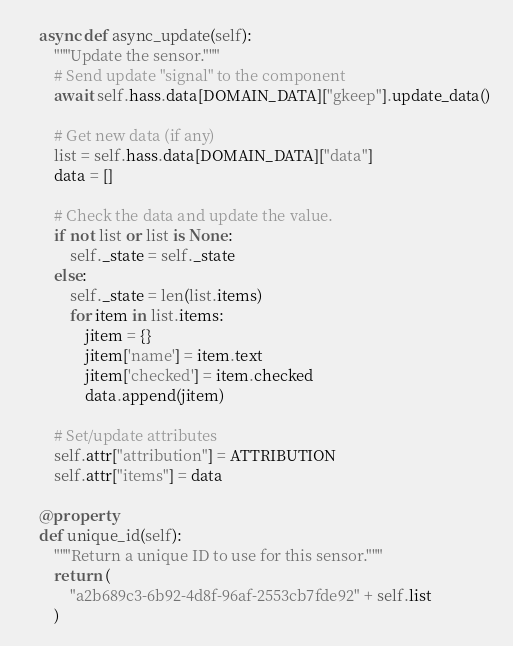Convert code to text. <code><loc_0><loc_0><loc_500><loc_500><_Python_>
    async def async_update(self):
        """Update the sensor."""
        # Send update "signal" to the component
        await self.hass.data[DOMAIN_DATA]["gkeep"].update_data()

        # Get new data (if any)
        list = self.hass.data[DOMAIN_DATA]["data"]
        data = []

        # Check the data and update the value.
        if not list or list is None:
            self._state = self._state
        else:
            self._state = len(list.items)
            for item in list.items:
                jitem = {}
                jitem['name'] = item.text
                jitem['checked'] = item.checked
                data.append(jitem)

        # Set/update attributes
        self.attr["attribution"] = ATTRIBUTION
        self.attr["items"] = data

    @property
    def unique_id(self):
        """Return a unique ID to use for this sensor."""
        return (
            "a2b689c3-6b92-4d8f-96af-2553cb7fde92" + self.list
        )  
</code> 